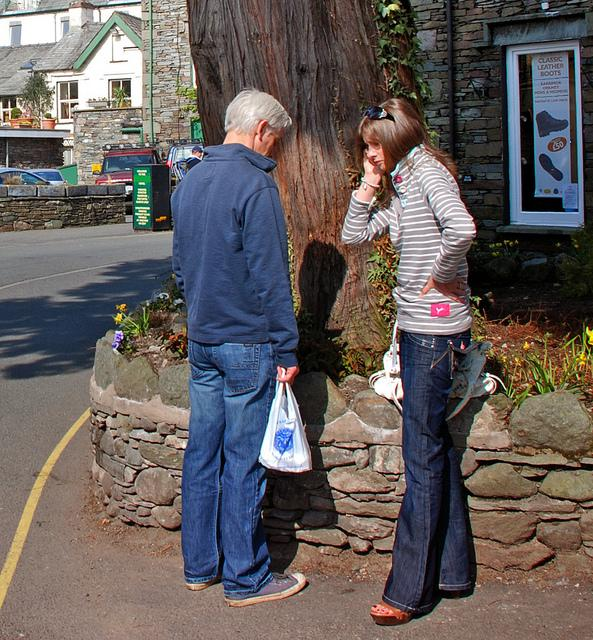What does the woman have in her right hand? phone 